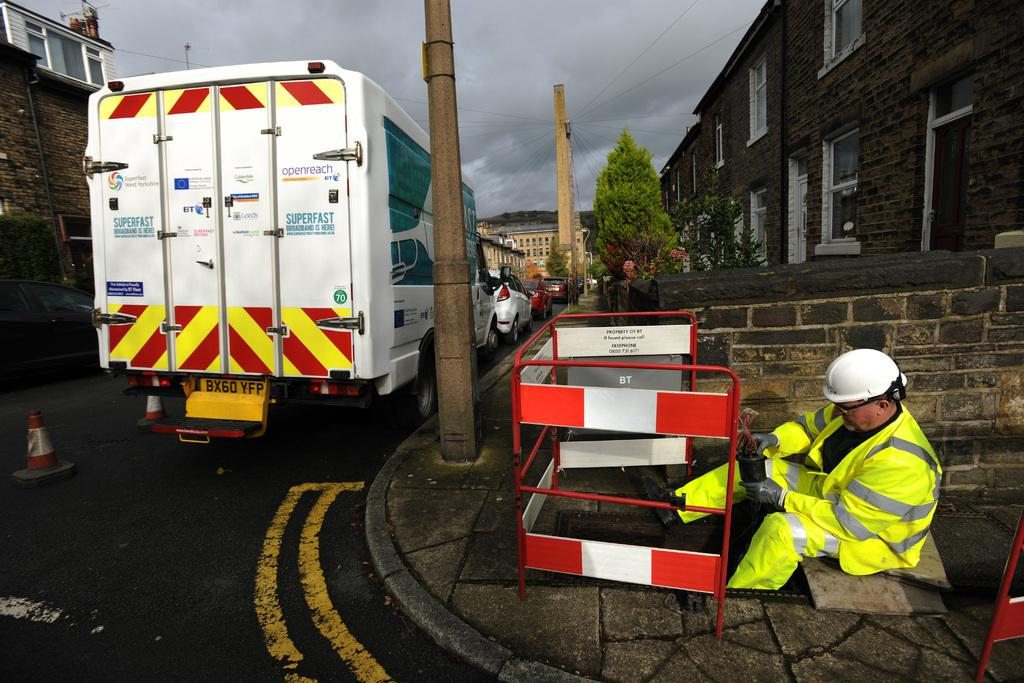What is the man doing in the image? The man is sitting on the right side of the image. What is the man wearing in the image? The man is wearing a green dress in the image. What can be seen moving on the road in the left side of the image? There is a vehicle moving on the road in the left side of the image. What color is the vehicle in the image? The vehicle is white in color. What is located in the middle of the image? There is a tree in the middle of the image. How many sisters does the man have in the image? There is no information about the man's sisters in the image. What type of voyage is the vehicle taking in the image? There is no indication of a voyage in the image; the vehicle is simply moving on the road. 